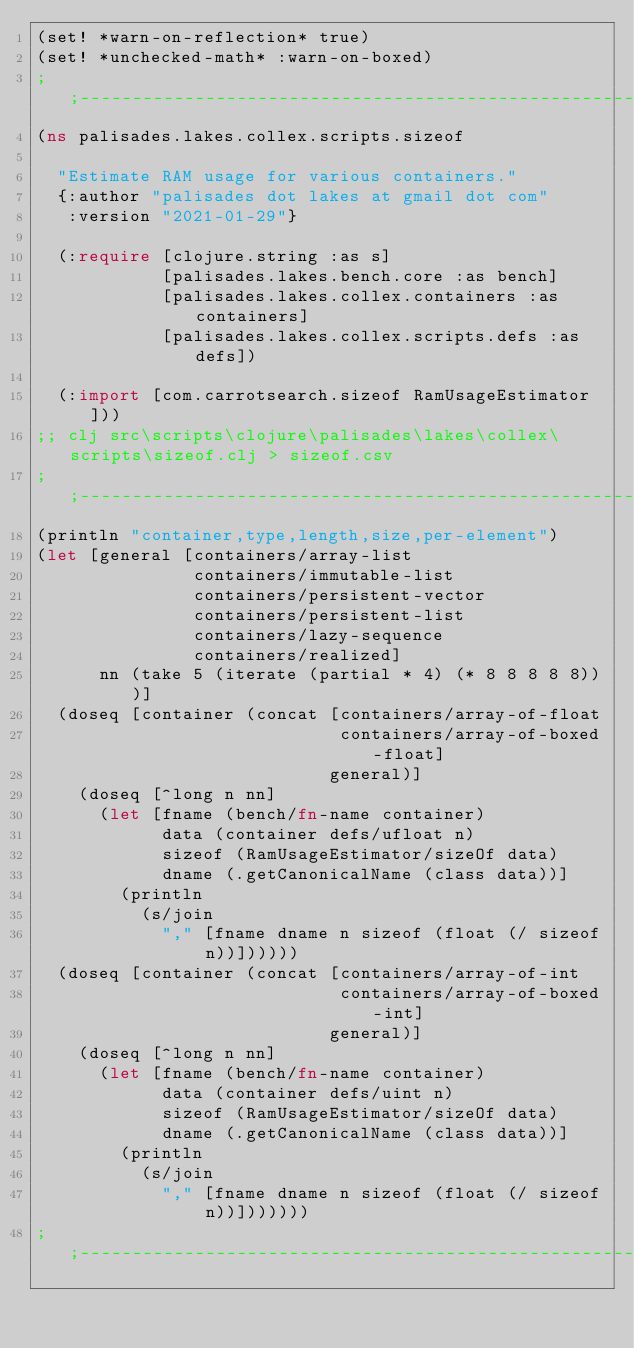<code> <loc_0><loc_0><loc_500><loc_500><_Clojure_>(set! *warn-on-reflection* true)
(set! *unchecked-math* :warn-on-boxed)
;;----------------------------------------------------------------
(ns palisades.lakes.collex.scripts.sizeof
  
  "Estimate RAM usage for various containers."
  {:author "palisades dot lakes at gmail dot com"
   :version "2021-01-29"}
  
  (:require [clojure.string :as s]
            [palisades.lakes.bench.core :as bench]
            [palisades.lakes.collex.containers :as containers]
            [palisades.lakes.collex.scripts.defs :as defs])
  
  (:import [com.carrotsearch.sizeof RamUsageEstimator]))
;; clj src\scripts\clojure\palisades\lakes\collex\scripts\sizeof.clj > sizeof.csv 
;;----------------------------------------------------------------
(println "container,type,length,size,per-element")
(let [general [containers/array-list
               containers/immutable-list
               containers/persistent-vector
               containers/persistent-list
               containers/lazy-sequence
               containers/realized]
      nn (take 5 (iterate (partial * 4) (* 8 8 8 8 8)))]
  (doseq [container (concat [containers/array-of-float 
                             containers/array-of-boxed-float]
                            general)]
    (doseq [^long n nn]
      (let [fname (bench/fn-name container)
            data (container defs/ufloat n)
            sizeof (RamUsageEstimator/sizeOf data)
            dname (.getCanonicalName (class data))]
        (println 
          (s/join 
            "," [fname dname n sizeof (float (/ sizeof n))])))))
  (doseq [container (concat [containers/array-of-int 
                             containers/array-of-boxed-int]
                            general)]
    (doseq [^long n nn]
      (let [fname (bench/fn-name container)
            data (container defs/uint n)
            sizeof (RamUsageEstimator/sizeOf data)
            dname (.getCanonicalName (class data))]
        (println 
          (s/join 
            "," [fname dname n sizeof (float (/ sizeof n))]))))))
;;----------------------------------------------------------------
</code> 